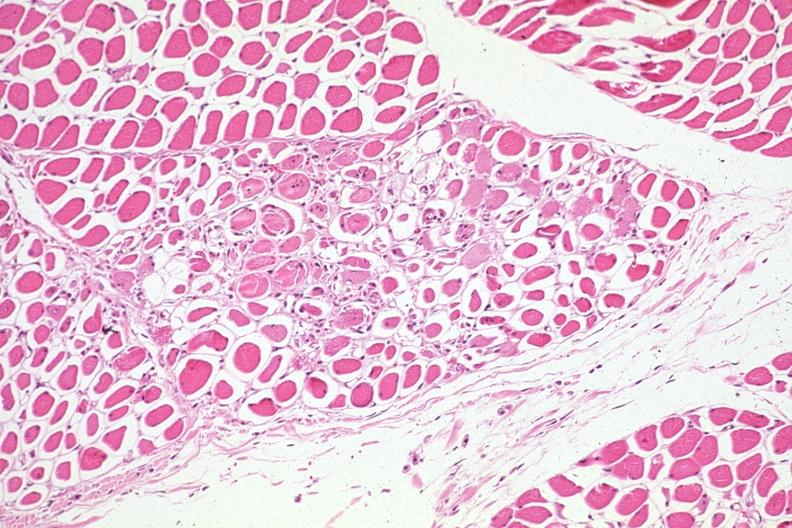how is lesions seen treated leukemia complicated by infection and dic?
Answer the question using a single word or phrase. Myelogenous 